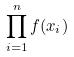Convert formula to latex. <formula><loc_0><loc_0><loc_500><loc_500>\prod _ { i = 1 } ^ { n } f ( x _ { i } )</formula> 